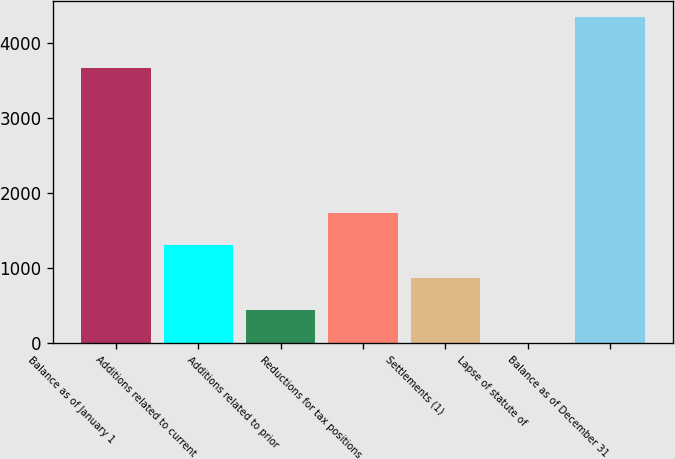Convert chart. <chart><loc_0><loc_0><loc_500><loc_500><bar_chart><fcel>Balance as of January 1<fcel>Additions related to current<fcel>Additions related to prior<fcel>Reductions for tax positions<fcel>Settlements (1)<fcel>Lapse of statute of<fcel>Balance as of December 31<nl><fcel>3665<fcel>1304.15<fcel>436.45<fcel>1738<fcel>870.3<fcel>2.6<fcel>4341.1<nl></chart> 